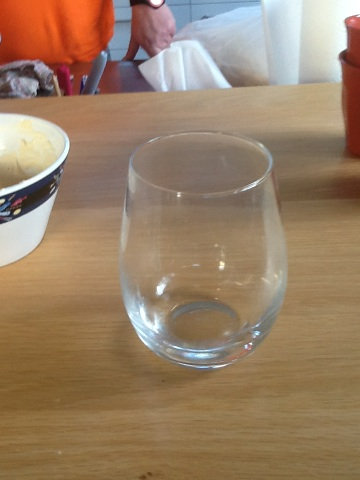What is this? This image shows a clear wine glass, typically used to serve white wine. Its design with no stem is known as a 'stemless' wine glass, which provides a modern look and prevents the glass from being knocked over easily. 